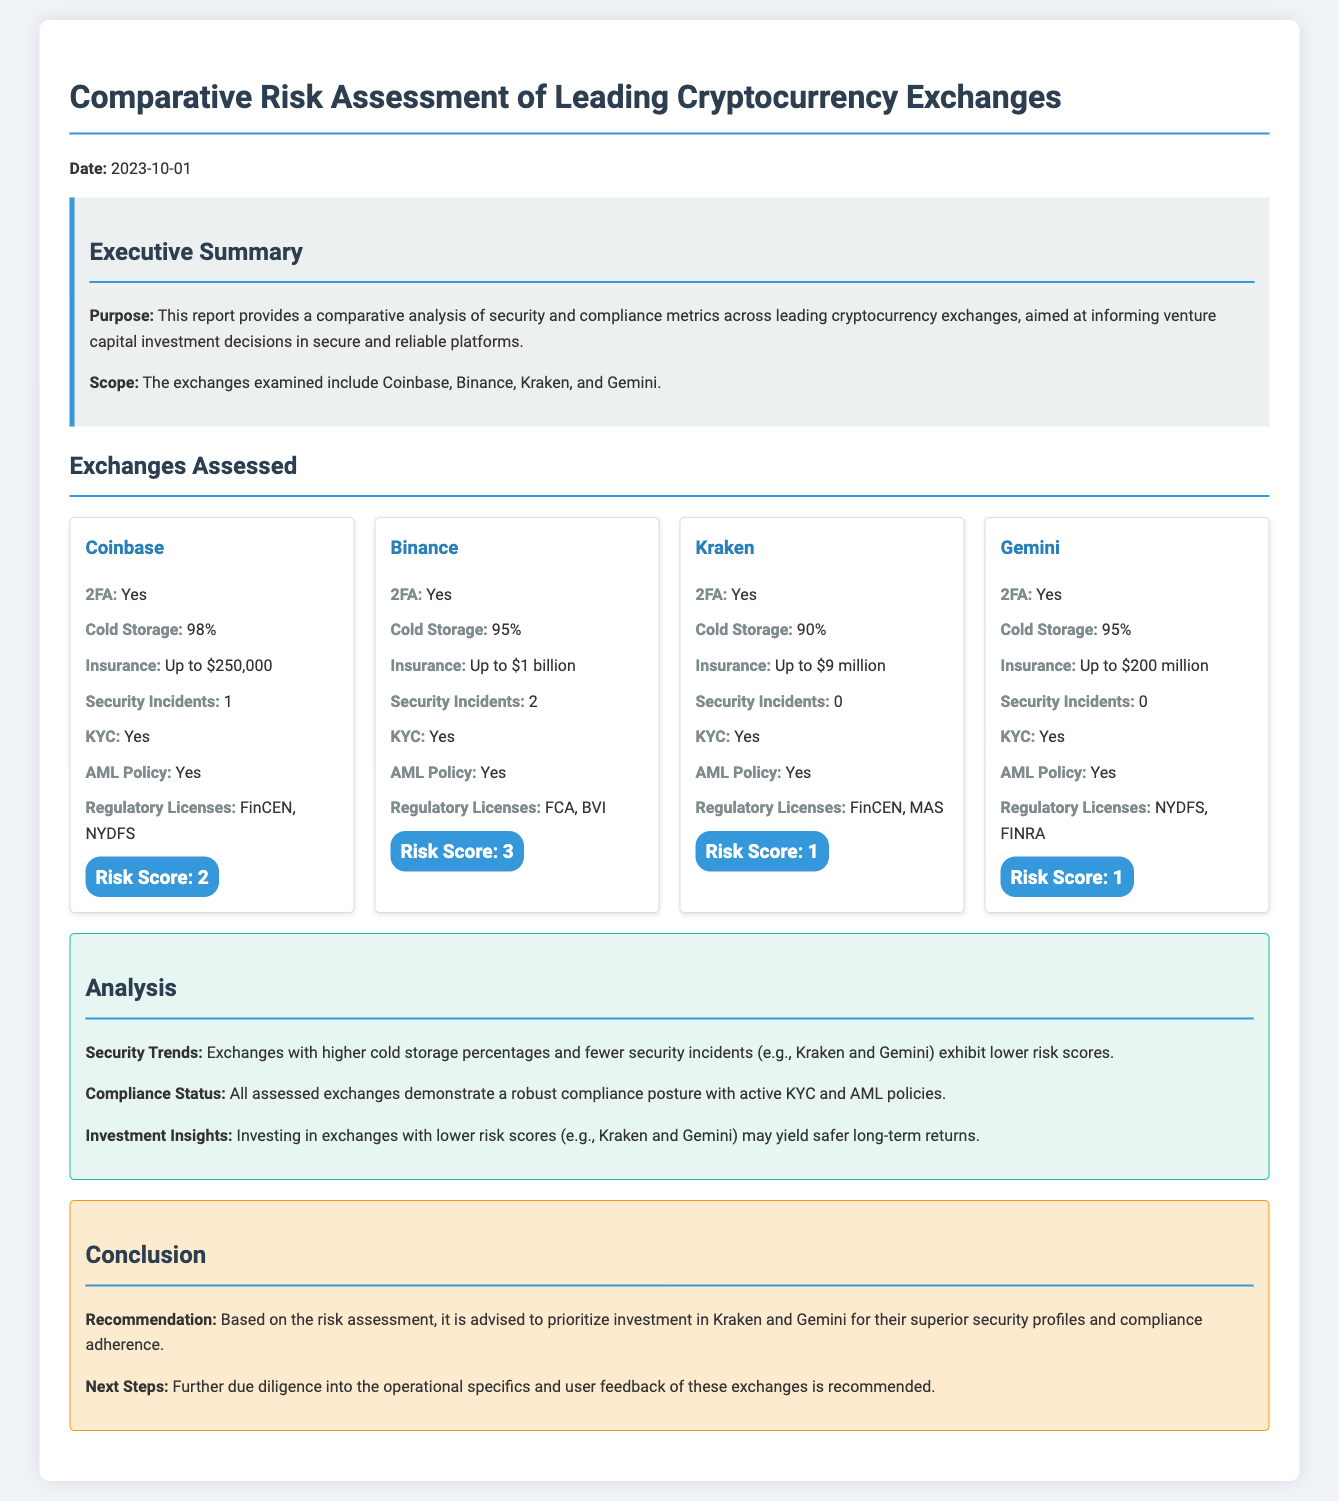What is the date of the report? The date indicates when the report was published, which is found at the top of the document.
Answer: 2023-10-01 How many security incidents has Kraken had? The total number of security incidents for each exchange is listed in their respective sections.
Answer: 0 What is the cold storage percentage for Coinbase? The cold storage percentage is specified for each exchange in the document, indicating their security measures.
Answer: 98% What is the insurance coverage for Binance? The insurance amounts are detailed within the exchange profiles, reflecting their security provisions.
Answer: Up to $1 billion Which exchange has the highest risk score? The risk scores for each exchange are clearly stated, allowing for easy comparison of their overall security assessments.
Answer: Binance Which two exchanges have the same risk score? This question asks for a deeper understanding by comparing the listed risk scores to see which ones match.
Answer: Kraken and Gemini What is the recommended exchange for investment according to the conclusion? The conclusion section summarizes the investment recommendations based on analysis, clearly stating which exchanges to prioritize.
Answer: Kraken and Gemini Which regulatory licenses does Gemini have? Regulatory licenses are mentioned under each exchange, giving insights into their compliance status.
Answer: NYDFS, FINRA What KYC status do all assessed exchanges share? The KYC status for each exchange is provided, indicating their compliance measures in the assessment.
Answer: Yes 